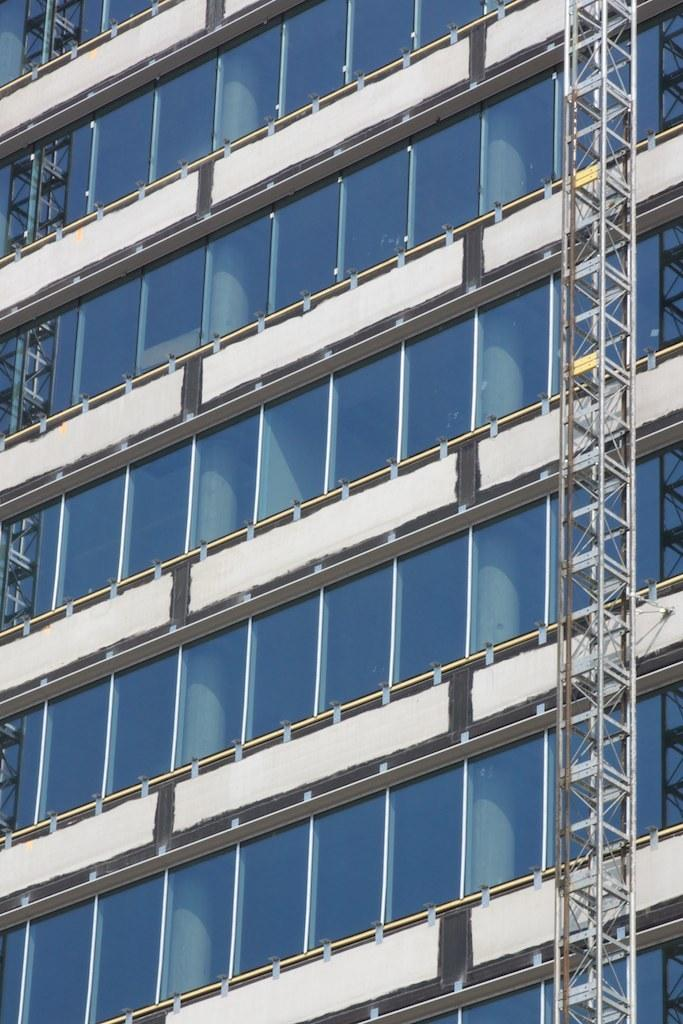What type of structure is visible in the image? There is a building in the image. What materials are used in the construction of the building? The building has glass elements and walls. Is there any specific feature in the image? Yes, there is a tower in the right corner of the image. What type of reward is being given to the fireman in the image? There is no fireman or reward present in the image; it only features a building with a tower. 